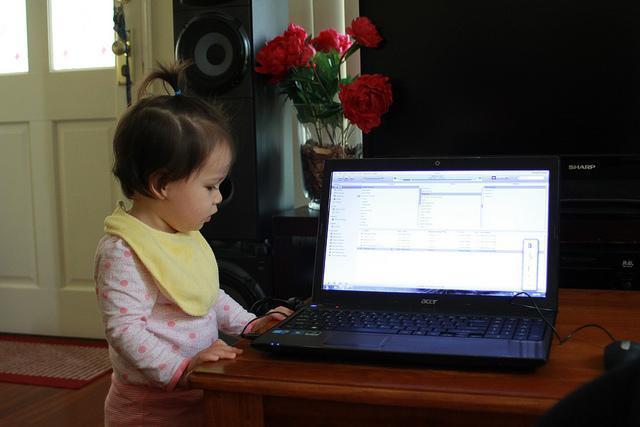How many tvs can be seen?
Give a very brief answer. 2. 